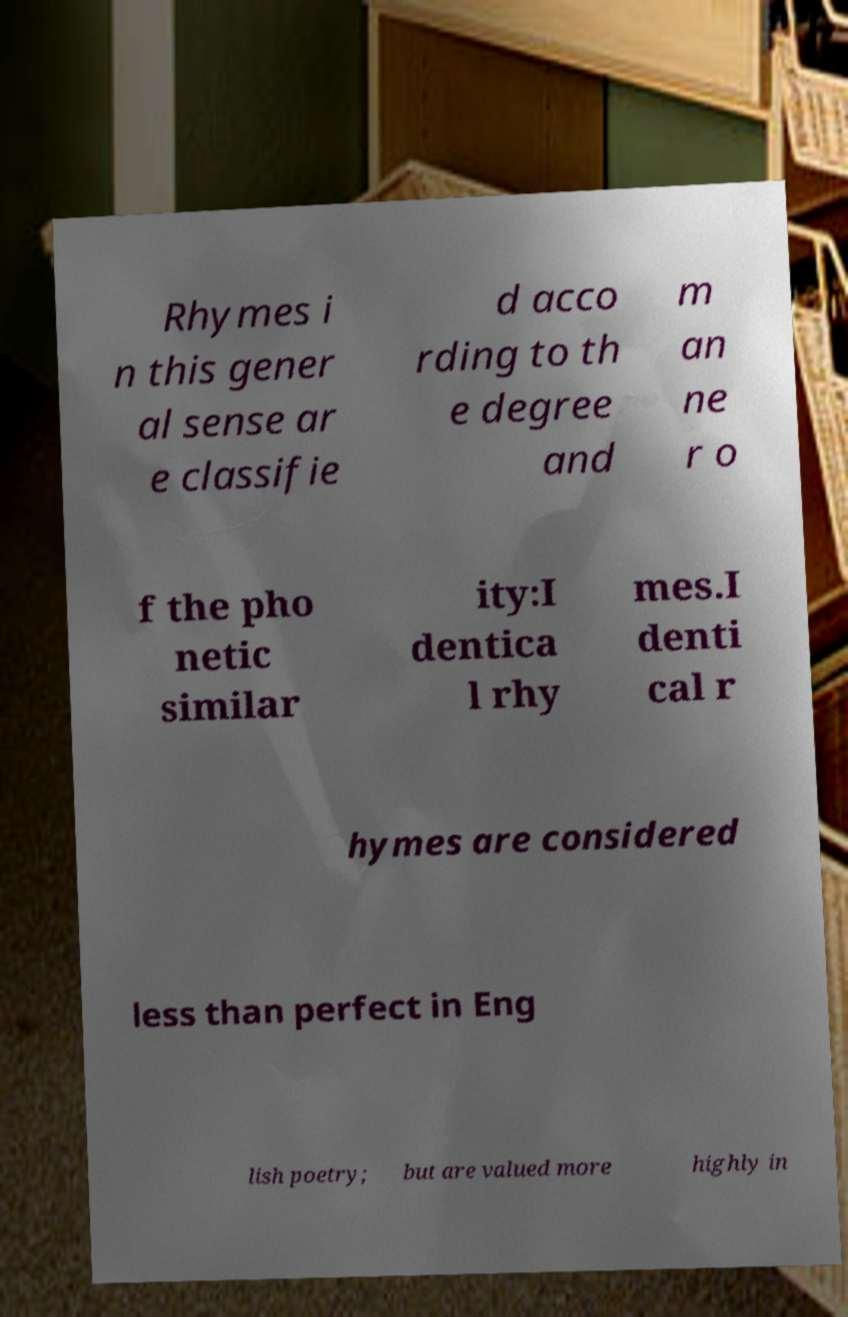Could you extract and type out the text from this image? Rhymes i n this gener al sense ar e classifie d acco rding to th e degree and m an ne r o f the pho netic similar ity:I dentica l rhy mes.I denti cal r hymes are considered less than perfect in Eng lish poetry; but are valued more highly in 